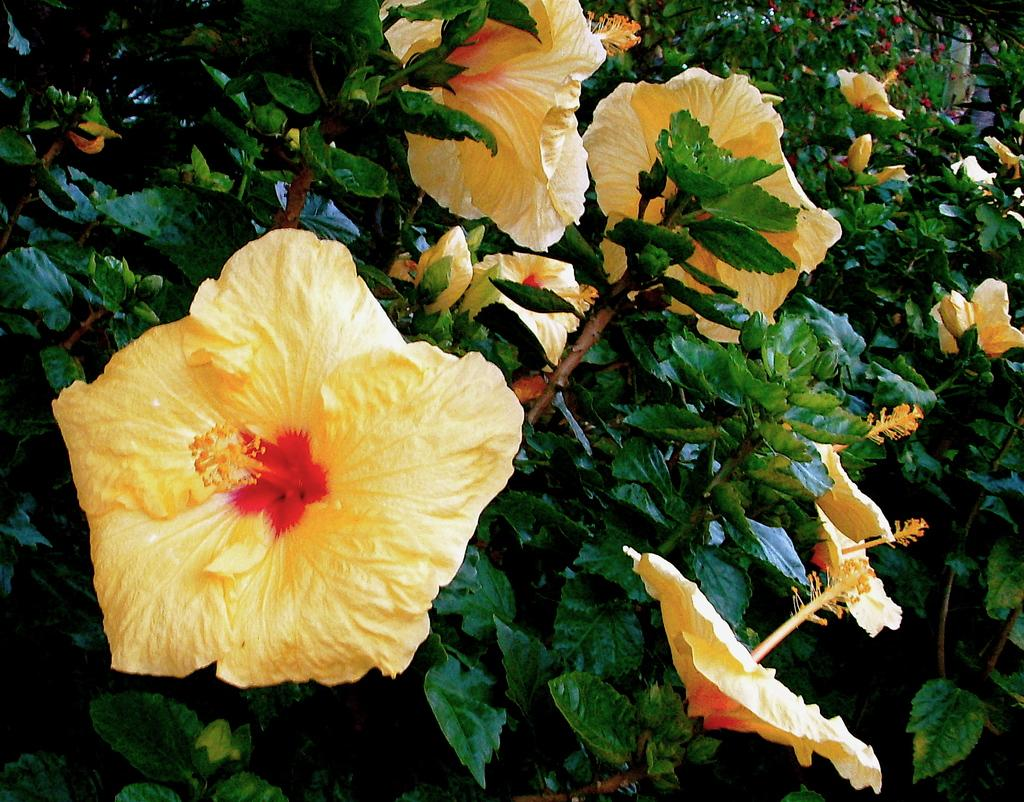What type of plants can be seen in the image? There are flowering plants in the image. Can you describe the appearance of the plants? The flowering plants have blooming flowers and green leaves. What might be the purpose of these plants in the image? The flowering plants may be for decoration or to attract pollinators. How many ears of corn can be seen on the flowering plants in the image? There is no corn present on the flowering plants in the image. 